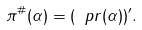Convert formula to latex. <formula><loc_0><loc_0><loc_500><loc_500>\label l { e q \colon c o t } \pi ^ { \# } ( \alpha ) = ( \ p r ( \alpha ) ) ^ { \prime } .</formula> 